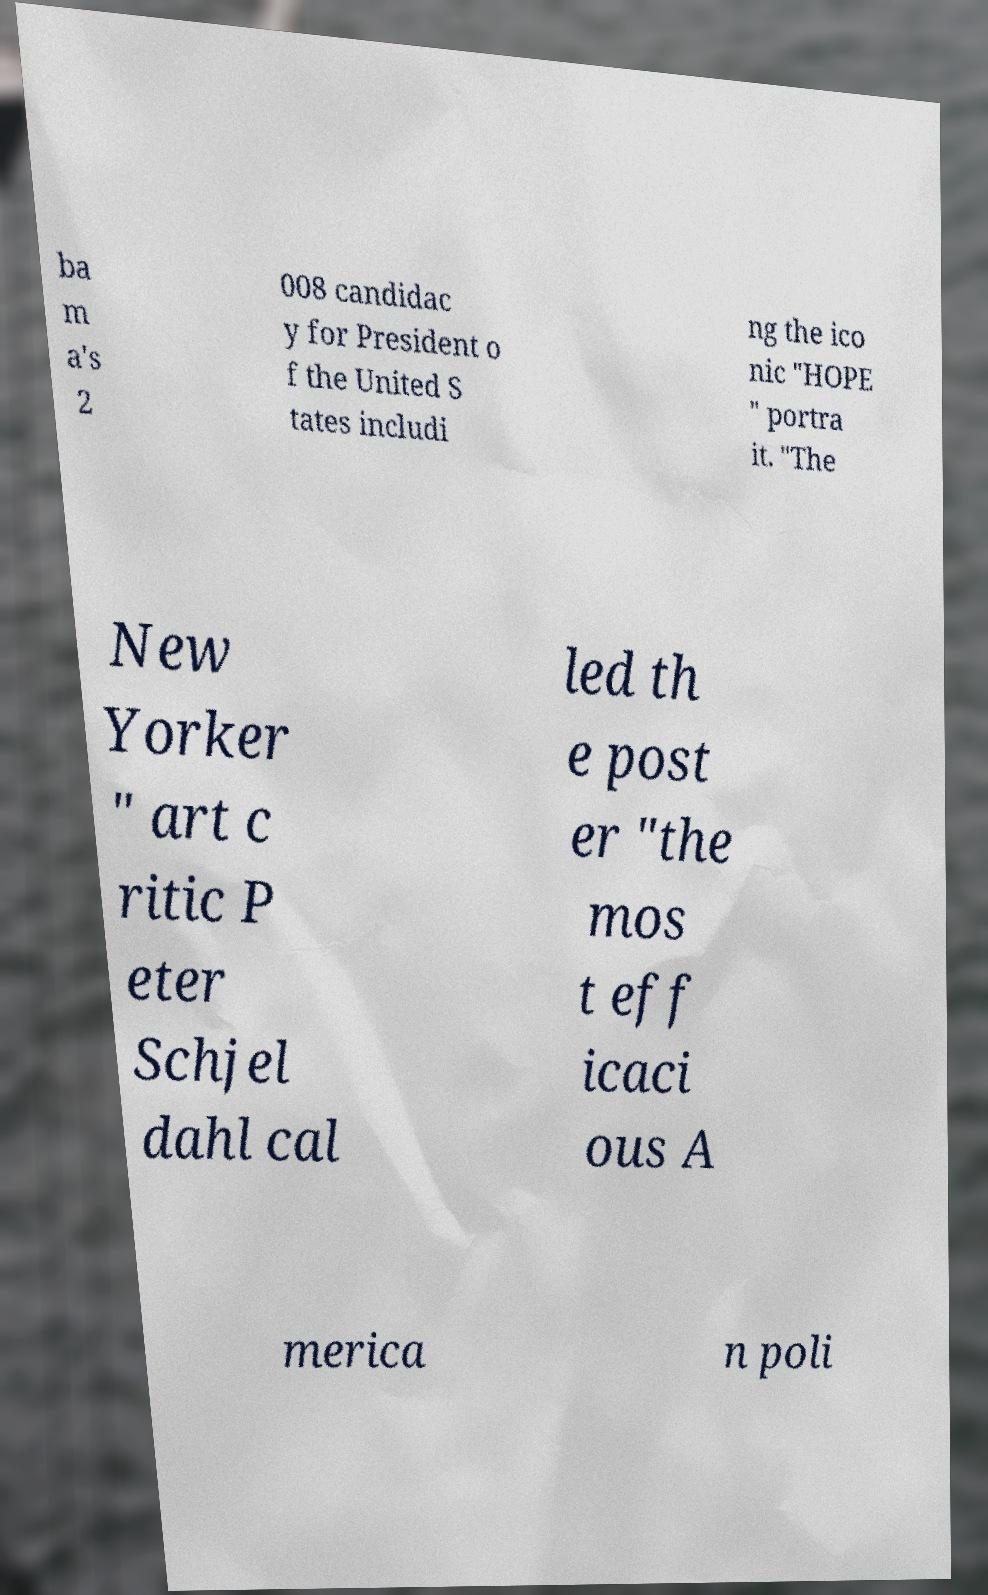Please read and relay the text visible in this image. What does it say? ba m a's 2 008 candidac y for President o f the United S tates includi ng the ico nic "HOPE " portra it. "The New Yorker " art c ritic P eter Schjel dahl cal led th e post er "the mos t eff icaci ous A merica n poli 